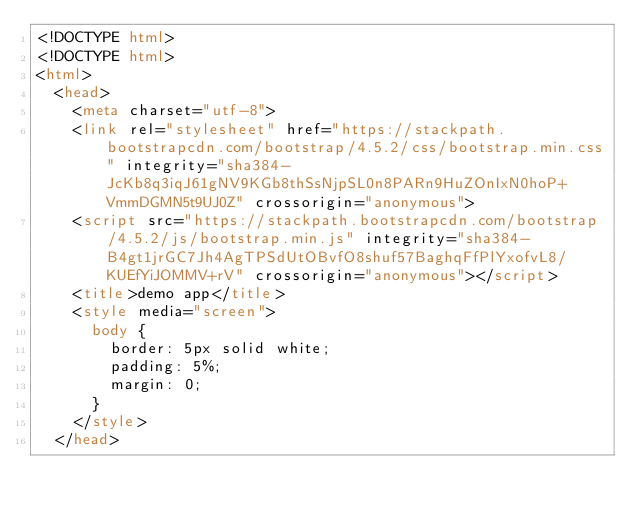Convert code to text. <code><loc_0><loc_0><loc_500><loc_500><_HTML_><!DOCTYPE html>
<!DOCTYPE html>
<html>
  <head>
    <meta charset="utf-8">
    <link rel="stylesheet" href="https://stackpath.bootstrapcdn.com/bootstrap/4.5.2/css/bootstrap.min.css" integrity="sha384-JcKb8q3iqJ61gNV9KGb8thSsNjpSL0n8PARn9HuZOnIxN0hoP+VmmDGMN5t9UJ0Z" crossorigin="anonymous">
    <script src="https://stackpath.bootstrapcdn.com/bootstrap/4.5.2/js/bootstrap.min.js" integrity="sha384-B4gt1jrGC7Jh4AgTPSdUtOBvfO8shuf57BaghqFfPlYxofvL8/KUEfYiJOMMV+rV" crossorigin="anonymous"></script>
    <title>demo app</title>
    <style media="screen">
      body {
        border: 5px solid white;
        padding: 5%;
        margin: 0;
      }
    </style>
  </head></code> 